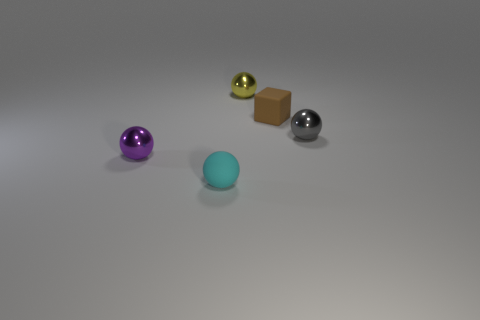Do the cube and the rubber ball have the same color?
Keep it short and to the point. No. What size is the rubber thing that is the same shape as the purple metallic thing?
Your answer should be compact. Small. How many large green things have the same material as the gray sphere?
Make the answer very short. 0. Is the material of the thing that is behind the brown matte object the same as the purple ball?
Provide a succinct answer. Yes. Are there an equal number of tiny cyan spheres that are right of the small yellow metallic object and yellow spheres?
Make the answer very short. No. How big is the yellow metal thing?
Your answer should be very brief. Small. How many balls have the same color as the cube?
Ensure brevity in your answer.  0. Is the yellow ball the same size as the brown thing?
Your answer should be compact. Yes. There is a matte object behind the small gray ball that is in front of the small yellow object; how big is it?
Your answer should be very brief. Small. Does the matte sphere have the same color as the ball behind the cube?
Your response must be concise. No. 